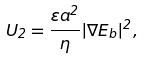<formula> <loc_0><loc_0><loc_500><loc_500>U _ { 2 } = \frac { \varepsilon a ^ { 2 } } { \eta } | \nabla E _ { b } | ^ { 2 } ,</formula> 